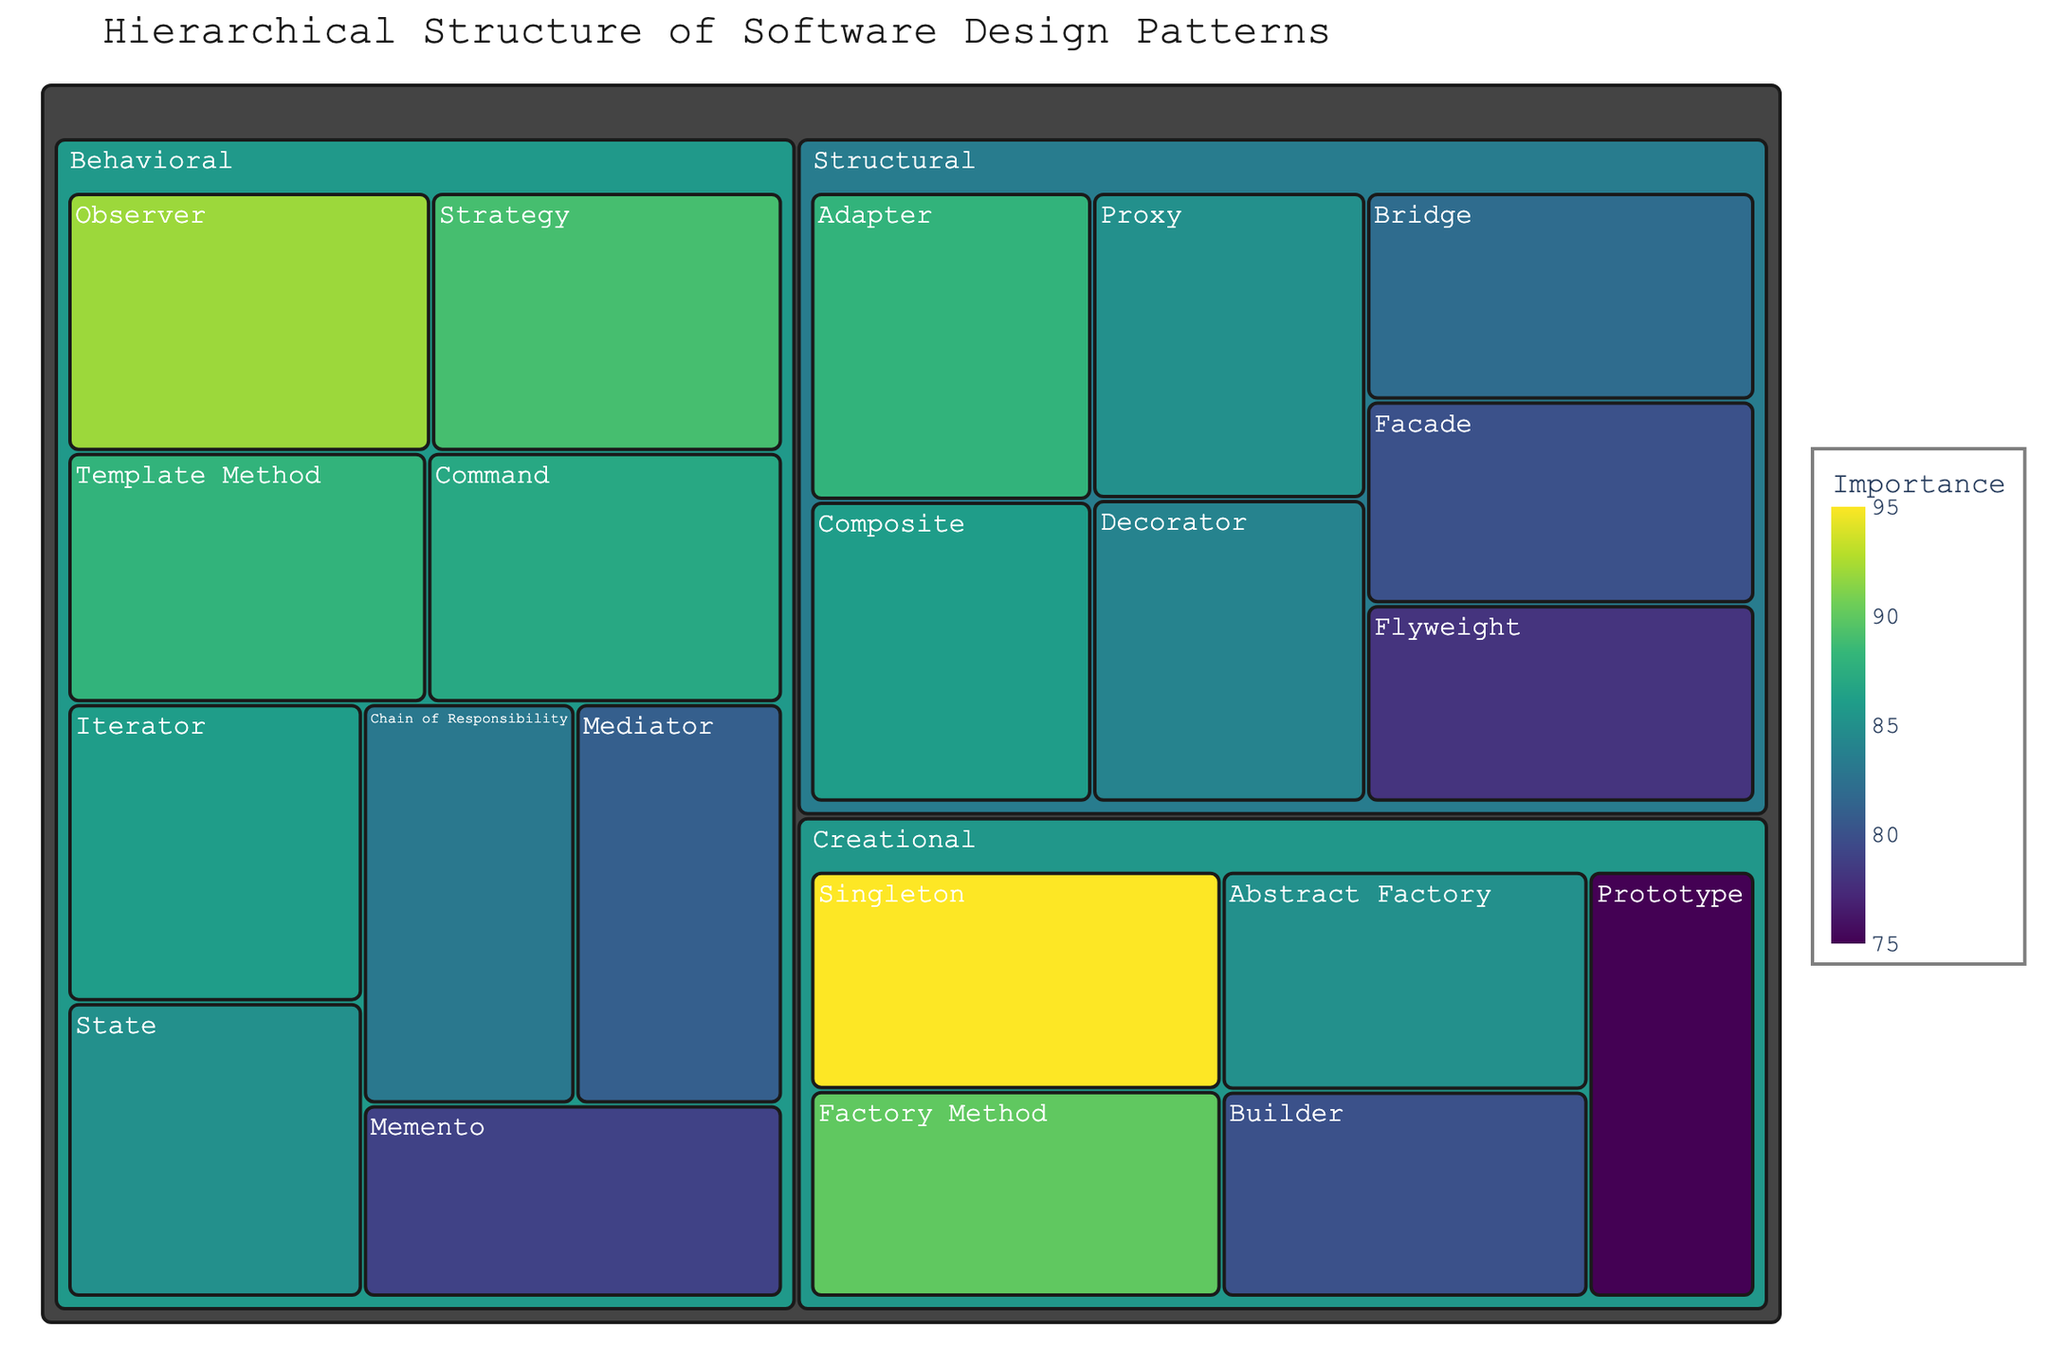What's the title of the figure? The title is typically found at the top of the figure. In this case, it reads "Hierarchical Structure of Software Design Patterns".
Answer: Hierarchical Structure of Software Design Patterns Which Creational pattern has the highest importance? To find the highest importance within the Creational category, look at the Creational section and identify the pattern with the largest value.
Answer: Singleton How many patterns are there in the Structural category? Count the number of tiles within the Structural section of the treemap.
Answer: 7 Which pattern, Structural or Behavioral, has a pattern with higher importance than 'Adapter'? Find the importance of 'Adapter' which is 88. Check the importance values of patterns in both Structural and Behavioral categories to see if any are higher. The 'Observer' pattern in the Behavioral category has an importance of 92 which is higher.
Answer: Behavioral What is the importance difference between the 'Observer' and 'Iterator' patterns? Identify the importance values for 'Observer' (92) and 'Iterator' (86) in the Behavioral category. Calculate the difference: 92 - 86.
Answer: 6 What's the total importance of all Creational patterns combined? Sum the importance values for all patterns in the Creational category: 95 (Singleton) + 90 (Factory Method) + 85 (Abstract Factory) + 80 (Builder) + 75 (Prototype) = 425.
Answer: 425 Which pattern has the lowest importance within the Behavioral category? Look at the Behavioral section and identify the pattern with the smallest value of importance.
Answer: Memento Between 'Composite' and 'Proxy' patterns, which has a higher importance and by how much? Compare the importance values for 'Composite' (86) and 'Proxy' (85) in the Structural category. Calculate the difference: 86 - 85.
Answer: Composite by 1 What is the average importance of patterns in the Behavioral category? Sum the importance values of all patterns in the Behavioral category and divide by the number of patterns: (92 + 89 + 87 + 85 + 83 + 86 + 81 + 79 + 88) / 9.
Answer: 85.55 Which category dominates the treemap in terms of the number of patterns? Count the number of tiles in each category (Creational, Structural, Behavioral).
Answer: Behavioral 